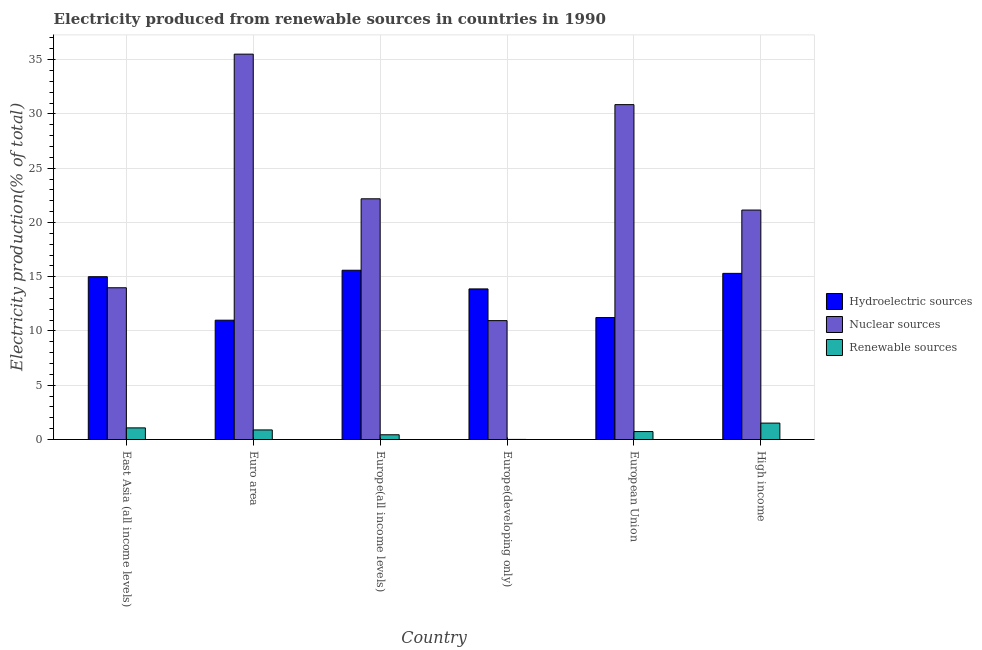How many different coloured bars are there?
Your answer should be compact. 3. Are the number of bars per tick equal to the number of legend labels?
Provide a short and direct response. Yes. How many bars are there on the 1st tick from the right?
Your response must be concise. 3. What is the label of the 1st group of bars from the left?
Keep it short and to the point. East Asia (all income levels). In how many cases, is the number of bars for a given country not equal to the number of legend labels?
Your answer should be very brief. 0. What is the percentage of electricity produced by nuclear sources in East Asia (all income levels)?
Ensure brevity in your answer.  13.99. Across all countries, what is the maximum percentage of electricity produced by renewable sources?
Give a very brief answer. 1.51. Across all countries, what is the minimum percentage of electricity produced by nuclear sources?
Provide a succinct answer. 10.96. In which country was the percentage of electricity produced by renewable sources minimum?
Provide a succinct answer. Europe(developing only). What is the total percentage of electricity produced by hydroelectric sources in the graph?
Make the answer very short. 82.02. What is the difference between the percentage of electricity produced by renewable sources in East Asia (all income levels) and that in Europe(developing only)?
Give a very brief answer. 1.06. What is the difference between the percentage of electricity produced by renewable sources in Euro area and the percentage of electricity produced by hydroelectric sources in Europe(all income levels)?
Your answer should be very brief. -14.71. What is the average percentage of electricity produced by hydroelectric sources per country?
Make the answer very short. 13.67. What is the difference between the percentage of electricity produced by nuclear sources and percentage of electricity produced by hydroelectric sources in Euro area?
Keep it short and to the point. 24.52. In how many countries, is the percentage of electricity produced by renewable sources greater than 35 %?
Keep it short and to the point. 0. What is the ratio of the percentage of electricity produced by hydroelectric sources in Europe(developing only) to that in High income?
Provide a short and direct response. 0.91. Is the difference between the percentage of electricity produced by hydroelectric sources in Europe(all income levels) and High income greater than the difference between the percentage of electricity produced by renewable sources in Europe(all income levels) and High income?
Keep it short and to the point. Yes. What is the difference between the highest and the second highest percentage of electricity produced by renewable sources?
Your response must be concise. 0.44. What is the difference between the highest and the lowest percentage of electricity produced by hydroelectric sources?
Keep it short and to the point. 4.6. What does the 1st bar from the left in East Asia (all income levels) represents?
Provide a short and direct response. Hydroelectric sources. What does the 1st bar from the right in East Asia (all income levels) represents?
Provide a succinct answer. Renewable sources. Are all the bars in the graph horizontal?
Your answer should be compact. No. How many countries are there in the graph?
Your answer should be very brief. 6. Are the values on the major ticks of Y-axis written in scientific E-notation?
Your response must be concise. No. How are the legend labels stacked?
Make the answer very short. Vertical. What is the title of the graph?
Offer a very short reply. Electricity produced from renewable sources in countries in 1990. What is the label or title of the X-axis?
Your answer should be very brief. Country. What is the Electricity production(% of total) of Hydroelectric sources in East Asia (all income levels)?
Provide a short and direct response. 15. What is the Electricity production(% of total) in Nuclear sources in East Asia (all income levels)?
Provide a short and direct response. 13.99. What is the Electricity production(% of total) of Renewable sources in East Asia (all income levels)?
Give a very brief answer. 1.07. What is the Electricity production(% of total) in Hydroelectric sources in Euro area?
Your answer should be compact. 10.99. What is the Electricity production(% of total) of Nuclear sources in Euro area?
Your answer should be very brief. 35.51. What is the Electricity production(% of total) in Renewable sources in Euro area?
Your response must be concise. 0.88. What is the Electricity production(% of total) in Hydroelectric sources in Europe(all income levels)?
Ensure brevity in your answer.  15.6. What is the Electricity production(% of total) of Nuclear sources in Europe(all income levels)?
Your answer should be compact. 22.18. What is the Electricity production(% of total) of Renewable sources in Europe(all income levels)?
Provide a succinct answer. 0.44. What is the Electricity production(% of total) in Hydroelectric sources in Europe(developing only)?
Offer a terse response. 13.88. What is the Electricity production(% of total) of Nuclear sources in Europe(developing only)?
Offer a very short reply. 10.96. What is the Electricity production(% of total) in Renewable sources in Europe(developing only)?
Your answer should be compact. 0.01. What is the Electricity production(% of total) in Hydroelectric sources in European Union?
Give a very brief answer. 11.24. What is the Electricity production(% of total) of Nuclear sources in European Union?
Make the answer very short. 30.86. What is the Electricity production(% of total) of Renewable sources in European Union?
Keep it short and to the point. 0.73. What is the Electricity production(% of total) in Hydroelectric sources in High income?
Provide a succinct answer. 15.31. What is the Electricity production(% of total) of Nuclear sources in High income?
Offer a very short reply. 21.14. What is the Electricity production(% of total) of Renewable sources in High income?
Make the answer very short. 1.51. Across all countries, what is the maximum Electricity production(% of total) in Hydroelectric sources?
Give a very brief answer. 15.6. Across all countries, what is the maximum Electricity production(% of total) of Nuclear sources?
Offer a terse response. 35.51. Across all countries, what is the maximum Electricity production(% of total) of Renewable sources?
Your response must be concise. 1.51. Across all countries, what is the minimum Electricity production(% of total) in Hydroelectric sources?
Give a very brief answer. 10.99. Across all countries, what is the minimum Electricity production(% of total) in Nuclear sources?
Make the answer very short. 10.96. Across all countries, what is the minimum Electricity production(% of total) of Renewable sources?
Provide a short and direct response. 0.01. What is the total Electricity production(% of total) in Hydroelectric sources in the graph?
Keep it short and to the point. 82.02. What is the total Electricity production(% of total) of Nuclear sources in the graph?
Offer a terse response. 134.64. What is the total Electricity production(% of total) of Renewable sources in the graph?
Provide a succinct answer. 4.65. What is the difference between the Electricity production(% of total) of Hydroelectric sources in East Asia (all income levels) and that in Euro area?
Offer a very short reply. 4.01. What is the difference between the Electricity production(% of total) of Nuclear sources in East Asia (all income levels) and that in Euro area?
Offer a terse response. -21.53. What is the difference between the Electricity production(% of total) of Renewable sources in East Asia (all income levels) and that in Euro area?
Your answer should be compact. 0.19. What is the difference between the Electricity production(% of total) of Hydroelectric sources in East Asia (all income levels) and that in Europe(all income levels)?
Provide a short and direct response. -0.59. What is the difference between the Electricity production(% of total) in Nuclear sources in East Asia (all income levels) and that in Europe(all income levels)?
Offer a very short reply. -8.2. What is the difference between the Electricity production(% of total) of Renewable sources in East Asia (all income levels) and that in Europe(all income levels)?
Your answer should be very brief. 0.64. What is the difference between the Electricity production(% of total) of Hydroelectric sources in East Asia (all income levels) and that in Europe(developing only)?
Give a very brief answer. 1.12. What is the difference between the Electricity production(% of total) of Nuclear sources in East Asia (all income levels) and that in Europe(developing only)?
Your answer should be compact. 3.03. What is the difference between the Electricity production(% of total) of Renewable sources in East Asia (all income levels) and that in Europe(developing only)?
Offer a very short reply. 1.06. What is the difference between the Electricity production(% of total) of Hydroelectric sources in East Asia (all income levels) and that in European Union?
Your answer should be very brief. 3.76. What is the difference between the Electricity production(% of total) in Nuclear sources in East Asia (all income levels) and that in European Union?
Your answer should be very brief. -16.87. What is the difference between the Electricity production(% of total) in Renewable sources in East Asia (all income levels) and that in European Union?
Provide a succinct answer. 0.34. What is the difference between the Electricity production(% of total) in Hydroelectric sources in East Asia (all income levels) and that in High income?
Provide a succinct answer. -0.31. What is the difference between the Electricity production(% of total) of Nuclear sources in East Asia (all income levels) and that in High income?
Give a very brief answer. -7.16. What is the difference between the Electricity production(% of total) in Renewable sources in East Asia (all income levels) and that in High income?
Your answer should be very brief. -0.44. What is the difference between the Electricity production(% of total) in Hydroelectric sources in Euro area and that in Europe(all income levels)?
Provide a short and direct response. -4.6. What is the difference between the Electricity production(% of total) in Nuclear sources in Euro area and that in Europe(all income levels)?
Provide a short and direct response. 13.33. What is the difference between the Electricity production(% of total) in Renewable sources in Euro area and that in Europe(all income levels)?
Your response must be concise. 0.45. What is the difference between the Electricity production(% of total) in Hydroelectric sources in Euro area and that in Europe(developing only)?
Ensure brevity in your answer.  -2.88. What is the difference between the Electricity production(% of total) in Nuclear sources in Euro area and that in Europe(developing only)?
Your response must be concise. 24.56. What is the difference between the Electricity production(% of total) in Renewable sources in Euro area and that in Europe(developing only)?
Provide a succinct answer. 0.87. What is the difference between the Electricity production(% of total) in Hydroelectric sources in Euro area and that in European Union?
Provide a short and direct response. -0.24. What is the difference between the Electricity production(% of total) of Nuclear sources in Euro area and that in European Union?
Give a very brief answer. 4.65. What is the difference between the Electricity production(% of total) in Renewable sources in Euro area and that in European Union?
Your answer should be compact. 0.15. What is the difference between the Electricity production(% of total) in Hydroelectric sources in Euro area and that in High income?
Provide a short and direct response. -4.32. What is the difference between the Electricity production(% of total) of Nuclear sources in Euro area and that in High income?
Keep it short and to the point. 14.37. What is the difference between the Electricity production(% of total) in Renewable sources in Euro area and that in High income?
Your answer should be compact. -0.63. What is the difference between the Electricity production(% of total) in Hydroelectric sources in Europe(all income levels) and that in Europe(developing only)?
Your answer should be compact. 1.72. What is the difference between the Electricity production(% of total) of Nuclear sources in Europe(all income levels) and that in Europe(developing only)?
Offer a very short reply. 11.23. What is the difference between the Electricity production(% of total) in Renewable sources in Europe(all income levels) and that in Europe(developing only)?
Your response must be concise. 0.43. What is the difference between the Electricity production(% of total) in Hydroelectric sources in Europe(all income levels) and that in European Union?
Your response must be concise. 4.36. What is the difference between the Electricity production(% of total) in Nuclear sources in Europe(all income levels) and that in European Union?
Ensure brevity in your answer.  -8.68. What is the difference between the Electricity production(% of total) in Renewable sources in Europe(all income levels) and that in European Union?
Provide a succinct answer. -0.3. What is the difference between the Electricity production(% of total) in Hydroelectric sources in Europe(all income levels) and that in High income?
Offer a very short reply. 0.29. What is the difference between the Electricity production(% of total) in Nuclear sources in Europe(all income levels) and that in High income?
Keep it short and to the point. 1.04. What is the difference between the Electricity production(% of total) in Renewable sources in Europe(all income levels) and that in High income?
Your answer should be very brief. -1.08. What is the difference between the Electricity production(% of total) of Hydroelectric sources in Europe(developing only) and that in European Union?
Provide a short and direct response. 2.64. What is the difference between the Electricity production(% of total) of Nuclear sources in Europe(developing only) and that in European Union?
Your response must be concise. -19.9. What is the difference between the Electricity production(% of total) in Renewable sources in Europe(developing only) and that in European Union?
Provide a short and direct response. -0.72. What is the difference between the Electricity production(% of total) in Hydroelectric sources in Europe(developing only) and that in High income?
Make the answer very short. -1.43. What is the difference between the Electricity production(% of total) of Nuclear sources in Europe(developing only) and that in High income?
Your answer should be very brief. -10.19. What is the difference between the Electricity production(% of total) in Renewable sources in Europe(developing only) and that in High income?
Offer a very short reply. -1.5. What is the difference between the Electricity production(% of total) in Hydroelectric sources in European Union and that in High income?
Give a very brief answer. -4.07. What is the difference between the Electricity production(% of total) of Nuclear sources in European Union and that in High income?
Give a very brief answer. 9.72. What is the difference between the Electricity production(% of total) in Renewable sources in European Union and that in High income?
Provide a short and direct response. -0.78. What is the difference between the Electricity production(% of total) of Hydroelectric sources in East Asia (all income levels) and the Electricity production(% of total) of Nuclear sources in Euro area?
Your answer should be compact. -20.51. What is the difference between the Electricity production(% of total) in Hydroelectric sources in East Asia (all income levels) and the Electricity production(% of total) in Renewable sources in Euro area?
Your answer should be very brief. 14.12. What is the difference between the Electricity production(% of total) in Nuclear sources in East Asia (all income levels) and the Electricity production(% of total) in Renewable sources in Euro area?
Your response must be concise. 13.1. What is the difference between the Electricity production(% of total) in Hydroelectric sources in East Asia (all income levels) and the Electricity production(% of total) in Nuclear sources in Europe(all income levels)?
Your response must be concise. -7.18. What is the difference between the Electricity production(% of total) in Hydroelectric sources in East Asia (all income levels) and the Electricity production(% of total) in Renewable sources in Europe(all income levels)?
Give a very brief answer. 14.57. What is the difference between the Electricity production(% of total) of Nuclear sources in East Asia (all income levels) and the Electricity production(% of total) of Renewable sources in Europe(all income levels)?
Give a very brief answer. 13.55. What is the difference between the Electricity production(% of total) in Hydroelectric sources in East Asia (all income levels) and the Electricity production(% of total) in Nuclear sources in Europe(developing only)?
Offer a very short reply. 4.05. What is the difference between the Electricity production(% of total) of Hydroelectric sources in East Asia (all income levels) and the Electricity production(% of total) of Renewable sources in Europe(developing only)?
Provide a succinct answer. 14.99. What is the difference between the Electricity production(% of total) in Nuclear sources in East Asia (all income levels) and the Electricity production(% of total) in Renewable sources in Europe(developing only)?
Provide a short and direct response. 13.98. What is the difference between the Electricity production(% of total) in Hydroelectric sources in East Asia (all income levels) and the Electricity production(% of total) in Nuclear sources in European Union?
Provide a short and direct response. -15.86. What is the difference between the Electricity production(% of total) of Hydroelectric sources in East Asia (all income levels) and the Electricity production(% of total) of Renewable sources in European Union?
Your answer should be compact. 14.27. What is the difference between the Electricity production(% of total) in Nuclear sources in East Asia (all income levels) and the Electricity production(% of total) in Renewable sources in European Union?
Provide a short and direct response. 13.25. What is the difference between the Electricity production(% of total) of Hydroelectric sources in East Asia (all income levels) and the Electricity production(% of total) of Nuclear sources in High income?
Provide a succinct answer. -6.14. What is the difference between the Electricity production(% of total) of Hydroelectric sources in East Asia (all income levels) and the Electricity production(% of total) of Renewable sources in High income?
Your response must be concise. 13.49. What is the difference between the Electricity production(% of total) in Nuclear sources in East Asia (all income levels) and the Electricity production(% of total) in Renewable sources in High income?
Offer a terse response. 12.47. What is the difference between the Electricity production(% of total) of Hydroelectric sources in Euro area and the Electricity production(% of total) of Nuclear sources in Europe(all income levels)?
Provide a succinct answer. -11.19. What is the difference between the Electricity production(% of total) in Hydroelectric sources in Euro area and the Electricity production(% of total) in Renewable sources in Europe(all income levels)?
Make the answer very short. 10.56. What is the difference between the Electricity production(% of total) in Nuclear sources in Euro area and the Electricity production(% of total) in Renewable sources in Europe(all income levels)?
Offer a terse response. 35.08. What is the difference between the Electricity production(% of total) of Hydroelectric sources in Euro area and the Electricity production(% of total) of Nuclear sources in Europe(developing only)?
Give a very brief answer. 0.04. What is the difference between the Electricity production(% of total) in Hydroelectric sources in Euro area and the Electricity production(% of total) in Renewable sources in Europe(developing only)?
Keep it short and to the point. 10.99. What is the difference between the Electricity production(% of total) of Nuclear sources in Euro area and the Electricity production(% of total) of Renewable sources in Europe(developing only)?
Your answer should be compact. 35.5. What is the difference between the Electricity production(% of total) in Hydroelectric sources in Euro area and the Electricity production(% of total) in Nuclear sources in European Union?
Provide a succinct answer. -19.86. What is the difference between the Electricity production(% of total) of Hydroelectric sources in Euro area and the Electricity production(% of total) of Renewable sources in European Union?
Your answer should be compact. 10.26. What is the difference between the Electricity production(% of total) in Nuclear sources in Euro area and the Electricity production(% of total) in Renewable sources in European Union?
Make the answer very short. 34.78. What is the difference between the Electricity production(% of total) of Hydroelectric sources in Euro area and the Electricity production(% of total) of Nuclear sources in High income?
Offer a very short reply. -10.15. What is the difference between the Electricity production(% of total) in Hydroelectric sources in Euro area and the Electricity production(% of total) in Renewable sources in High income?
Give a very brief answer. 9.48. What is the difference between the Electricity production(% of total) of Nuclear sources in Euro area and the Electricity production(% of total) of Renewable sources in High income?
Keep it short and to the point. 34. What is the difference between the Electricity production(% of total) of Hydroelectric sources in Europe(all income levels) and the Electricity production(% of total) of Nuclear sources in Europe(developing only)?
Give a very brief answer. 4.64. What is the difference between the Electricity production(% of total) of Hydroelectric sources in Europe(all income levels) and the Electricity production(% of total) of Renewable sources in Europe(developing only)?
Provide a succinct answer. 15.59. What is the difference between the Electricity production(% of total) of Nuclear sources in Europe(all income levels) and the Electricity production(% of total) of Renewable sources in Europe(developing only)?
Offer a very short reply. 22.17. What is the difference between the Electricity production(% of total) in Hydroelectric sources in Europe(all income levels) and the Electricity production(% of total) in Nuclear sources in European Union?
Give a very brief answer. -15.26. What is the difference between the Electricity production(% of total) in Hydroelectric sources in Europe(all income levels) and the Electricity production(% of total) in Renewable sources in European Union?
Offer a very short reply. 14.87. What is the difference between the Electricity production(% of total) of Nuclear sources in Europe(all income levels) and the Electricity production(% of total) of Renewable sources in European Union?
Make the answer very short. 21.45. What is the difference between the Electricity production(% of total) in Hydroelectric sources in Europe(all income levels) and the Electricity production(% of total) in Nuclear sources in High income?
Your answer should be very brief. -5.55. What is the difference between the Electricity production(% of total) in Hydroelectric sources in Europe(all income levels) and the Electricity production(% of total) in Renewable sources in High income?
Provide a succinct answer. 14.08. What is the difference between the Electricity production(% of total) of Nuclear sources in Europe(all income levels) and the Electricity production(% of total) of Renewable sources in High income?
Give a very brief answer. 20.67. What is the difference between the Electricity production(% of total) of Hydroelectric sources in Europe(developing only) and the Electricity production(% of total) of Nuclear sources in European Union?
Provide a succinct answer. -16.98. What is the difference between the Electricity production(% of total) in Hydroelectric sources in Europe(developing only) and the Electricity production(% of total) in Renewable sources in European Union?
Ensure brevity in your answer.  13.15. What is the difference between the Electricity production(% of total) of Nuclear sources in Europe(developing only) and the Electricity production(% of total) of Renewable sources in European Union?
Keep it short and to the point. 10.22. What is the difference between the Electricity production(% of total) of Hydroelectric sources in Europe(developing only) and the Electricity production(% of total) of Nuclear sources in High income?
Your answer should be very brief. -7.27. What is the difference between the Electricity production(% of total) in Hydroelectric sources in Europe(developing only) and the Electricity production(% of total) in Renewable sources in High income?
Your response must be concise. 12.37. What is the difference between the Electricity production(% of total) of Nuclear sources in Europe(developing only) and the Electricity production(% of total) of Renewable sources in High income?
Provide a short and direct response. 9.44. What is the difference between the Electricity production(% of total) of Hydroelectric sources in European Union and the Electricity production(% of total) of Nuclear sources in High income?
Ensure brevity in your answer.  -9.91. What is the difference between the Electricity production(% of total) in Hydroelectric sources in European Union and the Electricity production(% of total) in Renewable sources in High income?
Ensure brevity in your answer.  9.73. What is the difference between the Electricity production(% of total) of Nuclear sources in European Union and the Electricity production(% of total) of Renewable sources in High income?
Ensure brevity in your answer.  29.35. What is the average Electricity production(% of total) in Hydroelectric sources per country?
Ensure brevity in your answer.  13.67. What is the average Electricity production(% of total) in Nuclear sources per country?
Your response must be concise. 22.44. What is the average Electricity production(% of total) in Renewable sources per country?
Provide a succinct answer. 0.77. What is the difference between the Electricity production(% of total) of Hydroelectric sources and Electricity production(% of total) of Nuclear sources in East Asia (all income levels)?
Your answer should be very brief. 1.02. What is the difference between the Electricity production(% of total) of Hydroelectric sources and Electricity production(% of total) of Renewable sources in East Asia (all income levels)?
Give a very brief answer. 13.93. What is the difference between the Electricity production(% of total) in Nuclear sources and Electricity production(% of total) in Renewable sources in East Asia (all income levels)?
Offer a very short reply. 12.91. What is the difference between the Electricity production(% of total) of Hydroelectric sources and Electricity production(% of total) of Nuclear sources in Euro area?
Ensure brevity in your answer.  -24.52. What is the difference between the Electricity production(% of total) of Hydroelectric sources and Electricity production(% of total) of Renewable sources in Euro area?
Provide a succinct answer. 10.11. What is the difference between the Electricity production(% of total) of Nuclear sources and Electricity production(% of total) of Renewable sources in Euro area?
Keep it short and to the point. 34.63. What is the difference between the Electricity production(% of total) in Hydroelectric sources and Electricity production(% of total) in Nuclear sources in Europe(all income levels)?
Offer a very short reply. -6.58. What is the difference between the Electricity production(% of total) of Hydroelectric sources and Electricity production(% of total) of Renewable sources in Europe(all income levels)?
Provide a short and direct response. 15.16. What is the difference between the Electricity production(% of total) in Nuclear sources and Electricity production(% of total) in Renewable sources in Europe(all income levels)?
Give a very brief answer. 21.74. What is the difference between the Electricity production(% of total) in Hydroelectric sources and Electricity production(% of total) in Nuclear sources in Europe(developing only)?
Keep it short and to the point. 2.92. What is the difference between the Electricity production(% of total) of Hydroelectric sources and Electricity production(% of total) of Renewable sources in Europe(developing only)?
Provide a succinct answer. 13.87. What is the difference between the Electricity production(% of total) in Nuclear sources and Electricity production(% of total) in Renewable sources in Europe(developing only)?
Keep it short and to the point. 10.95. What is the difference between the Electricity production(% of total) of Hydroelectric sources and Electricity production(% of total) of Nuclear sources in European Union?
Make the answer very short. -19.62. What is the difference between the Electricity production(% of total) of Hydroelectric sources and Electricity production(% of total) of Renewable sources in European Union?
Your answer should be compact. 10.51. What is the difference between the Electricity production(% of total) of Nuclear sources and Electricity production(% of total) of Renewable sources in European Union?
Offer a terse response. 30.13. What is the difference between the Electricity production(% of total) in Hydroelectric sources and Electricity production(% of total) in Nuclear sources in High income?
Provide a succinct answer. -5.83. What is the difference between the Electricity production(% of total) in Hydroelectric sources and Electricity production(% of total) in Renewable sources in High income?
Make the answer very short. 13.8. What is the difference between the Electricity production(% of total) of Nuclear sources and Electricity production(% of total) of Renewable sources in High income?
Keep it short and to the point. 19.63. What is the ratio of the Electricity production(% of total) of Hydroelectric sources in East Asia (all income levels) to that in Euro area?
Your answer should be very brief. 1.36. What is the ratio of the Electricity production(% of total) of Nuclear sources in East Asia (all income levels) to that in Euro area?
Your answer should be compact. 0.39. What is the ratio of the Electricity production(% of total) in Renewable sources in East Asia (all income levels) to that in Euro area?
Provide a succinct answer. 1.21. What is the ratio of the Electricity production(% of total) of Hydroelectric sources in East Asia (all income levels) to that in Europe(all income levels)?
Keep it short and to the point. 0.96. What is the ratio of the Electricity production(% of total) in Nuclear sources in East Asia (all income levels) to that in Europe(all income levels)?
Your response must be concise. 0.63. What is the ratio of the Electricity production(% of total) of Renewable sources in East Asia (all income levels) to that in Europe(all income levels)?
Your answer should be compact. 2.45. What is the ratio of the Electricity production(% of total) in Hydroelectric sources in East Asia (all income levels) to that in Europe(developing only)?
Offer a terse response. 1.08. What is the ratio of the Electricity production(% of total) in Nuclear sources in East Asia (all income levels) to that in Europe(developing only)?
Give a very brief answer. 1.28. What is the ratio of the Electricity production(% of total) in Renewable sources in East Asia (all income levels) to that in Europe(developing only)?
Make the answer very short. 111.13. What is the ratio of the Electricity production(% of total) in Hydroelectric sources in East Asia (all income levels) to that in European Union?
Your response must be concise. 1.33. What is the ratio of the Electricity production(% of total) of Nuclear sources in East Asia (all income levels) to that in European Union?
Your answer should be compact. 0.45. What is the ratio of the Electricity production(% of total) in Renewable sources in East Asia (all income levels) to that in European Union?
Provide a succinct answer. 1.46. What is the ratio of the Electricity production(% of total) in Hydroelectric sources in East Asia (all income levels) to that in High income?
Your answer should be very brief. 0.98. What is the ratio of the Electricity production(% of total) in Nuclear sources in East Asia (all income levels) to that in High income?
Provide a short and direct response. 0.66. What is the ratio of the Electricity production(% of total) in Renewable sources in East Asia (all income levels) to that in High income?
Provide a succinct answer. 0.71. What is the ratio of the Electricity production(% of total) of Hydroelectric sources in Euro area to that in Europe(all income levels)?
Ensure brevity in your answer.  0.7. What is the ratio of the Electricity production(% of total) in Nuclear sources in Euro area to that in Europe(all income levels)?
Provide a short and direct response. 1.6. What is the ratio of the Electricity production(% of total) of Renewable sources in Euro area to that in Europe(all income levels)?
Ensure brevity in your answer.  2.02. What is the ratio of the Electricity production(% of total) of Hydroelectric sources in Euro area to that in Europe(developing only)?
Offer a very short reply. 0.79. What is the ratio of the Electricity production(% of total) of Nuclear sources in Euro area to that in Europe(developing only)?
Your answer should be compact. 3.24. What is the ratio of the Electricity production(% of total) of Renewable sources in Euro area to that in Europe(developing only)?
Ensure brevity in your answer.  91.58. What is the ratio of the Electricity production(% of total) in Hydroelectric sources in Euro area to that in European Union?
Keep it short and to the point. 0.98. What is the ratio of the Electricity production(% of total) in Nuclear sources in Euro area to that in European Union?
Provide a succinct answer. 1.15. What is the ratio of the Electricity production(% of total) in Renewable sources in Euro area to that in European Union?
Make the answer very short. 1.21. What is the ratio of the Electricity production(% of total) in Hydroelectric sources in Euro area to that in High income?
Ensure brevity in your answer.  0.72. What is the ratio of the Electricity production(% of total) in Nuclear sources in Euro area to that in High income?
Offer a terse response. 1.68. What is the ratio of the Electricity production(% of total) of Renewable sources in Euro area to that in High income?
Offer a very short reply. 0.58. What is the ratio of the Electricity production(% of total) of Hydroelectric sources in Europe(all income levels) to that in Europe(developing only)?
Offer a terse response. 1.12. What is the ratio of the Electricity production(% of total) of Nuclear sources in Europe(all income levels) to that in Europe(developing only)?
Provide a succinct answer. 2.02. What is the ratio of the Electricity production(% of total) in Renewable sources in Europe(all income levels) to that in Europe(developing only)?
Provide a succinct answer. 45.29. What is the ratio of the Electricity production(% of total) of Hydroelectric sources in Europe(all income levels) to that in European Union?
Ensure brevity in your answer.  1.39. What is the ratio of the Electricity production(% of total) of Nuclear sources in Europe(all income levels) to that in European Union?
Ensure brevity in your answer.  0.72. What is the ratio of the Electricity production(% of total) of Renewable sources in Europe(all income levels) to that in European Union?
Provide a succinct answer. 0.6. What is the ratio of the Electricity production(% of total) of Hydroelectric sources in Europe(all income levels) to that in High income?
Make the answer very short. 1.02. What is the ratio of the Electricity production(% of total) of Nuclear sources in Europe(all income levels) to that in High income?
Your response must be concise. 1.05. What is the ratio of the Electricity production(% of total) of Renewable sources in Europe(all income levels) to that in High income?
Make the answer very short. 0.29. What is the ratio of the Electricity production(% of total) of Hydroelectric sources in Europe(developing only) to that in European Union?
Offer a very short reply. 1.23. What is the ratio of the Electricity production(% of total) in Nuclear sources in Europe(developing only) to that in European Union?
Your answer should be compact. 0.35. What is the ratio of the Electricity production(% of total) of Renewable sources in Europe(developing only) to that in European Union?
Offer a terse response. 0.01. What is the ratio of the Electricity production(% of total) in Hydroelectric sources in Europe(developing only) to that in High income?
Give a very brief answer. 0.91. What is the ratio of the Electricity production(% of total) of Nuclear sources in Europe(developing only) to that in High income?
Give a very brief answer. 0.52. What is the ratio of the Electricity production(% of total) of Renewable sources in Europe(developing only) to that in High income?
Offer a terse response. 0.01. What is the ratio of the Electricity production(% of total) of Hydroelectric sources in European Union to that in High income?
Keep it short and to the point. 0.73. What is the ratio of the Electricity production(% of total) in Nuclear sources in European Union to that in High income?
Give a very brief answer. 1.46. What is the ratio of the Electricity production(% of total) of Renewable sources in European Union to that in High income?
Make the answer very short. 0.48. What is the difference between the highest and the second highest Electricity production(% of total) of Hydroelectric sources?
Your response must be concise. 0.29. What is the difference between the highest and the second highest Electricity production(% of total) in Nuclear sources?
Ensure brevity in your answer.  4.65. What is the difference between the highest and the second highest Electricity production(% of total) of Renewable sources?
Offer a terse response. 0.44. What is the difference between the highest and the lowest Electricity production(% of total) in Hydroelectric sources?
Provide a succinct answer. 4.6. What is the difference between the highest and the lowest Electricity production(% of total) in Nuclear sources?
Your response must be concise. 24.56. What is the difference between the highest and the lowest Electricity production(% of total) of Renewable sources?
Keep it short and to the point. 1.5. 